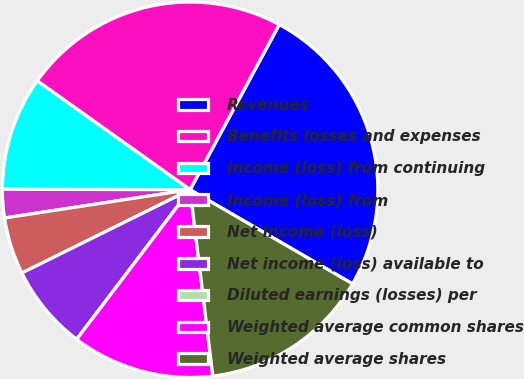<chart> <loc_0><loc_0><loc_500><loc_500><pie_chart><fcel>Revenues<fcel>Benefits losses and expenses<fcel>Income (loss) from continuing<fcel>Income (loss) from<fcel>Net income (loss)<fcel>Net income (loss) available to<fcel>Diluted earnings (losses) per<fcel>Weighted average common shares<fcel>Weighted average shares<nl><fcel>25.48%<fcel>23.03%<fcel>9.81%<fcel>2.45%<fcel>4.91%<fcel>7.36%<fcel>0.0%<fcel>12.26%<fcel>14.71%<nl></chart> 